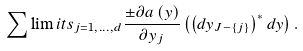Convert formula to latex. <formula><loc_0><loc_0><loc_500><loc_500>\sum \lim i t s _ { j = 1 , \dots , d } \frac { \pm \partial a \left ( y \right ) } { \partial y _ { j } } \left ( \left ( d y _ { J - \left \{ j \right \} } \right ) ^ { * } d y \right ) .</formula> 